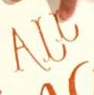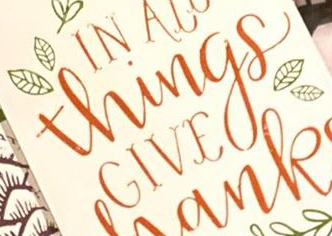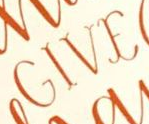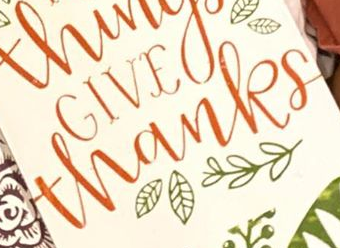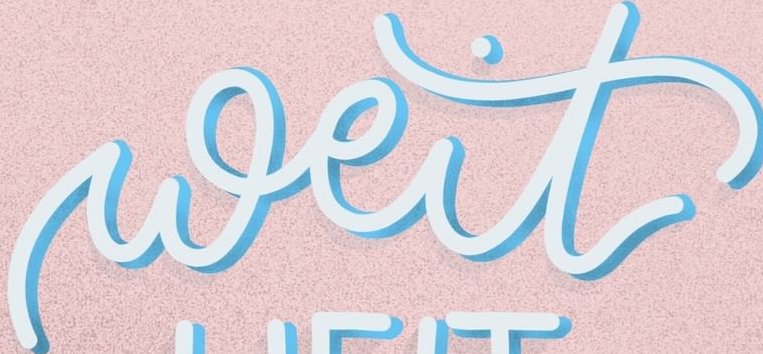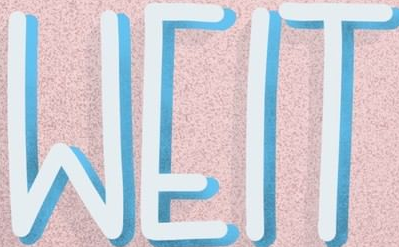What words can you see in these images in sequence, separated by a semicolon? ALL; Things; GIVE; thanks; weit; WEIT 